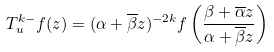<formula> <loc_0><loc_0><loc_500><loc_500>T ^ { k - } _ { u } f ( z ) = ( \alpha + \overline { \beta } z ) ^ { - 2 k } f \left ( \frac { \beta + \overline { \alpha } z } { \alpha + \overline { \beta } z } \right )</formula> 